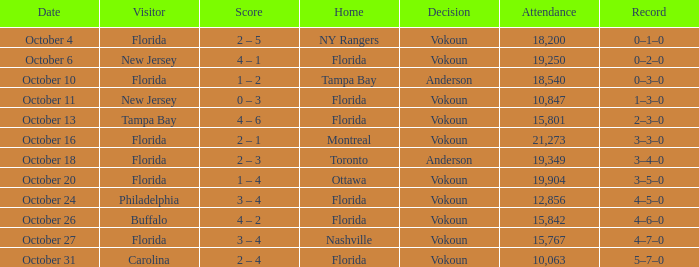Which team won when the visitor was Carolina? Vokoun. 